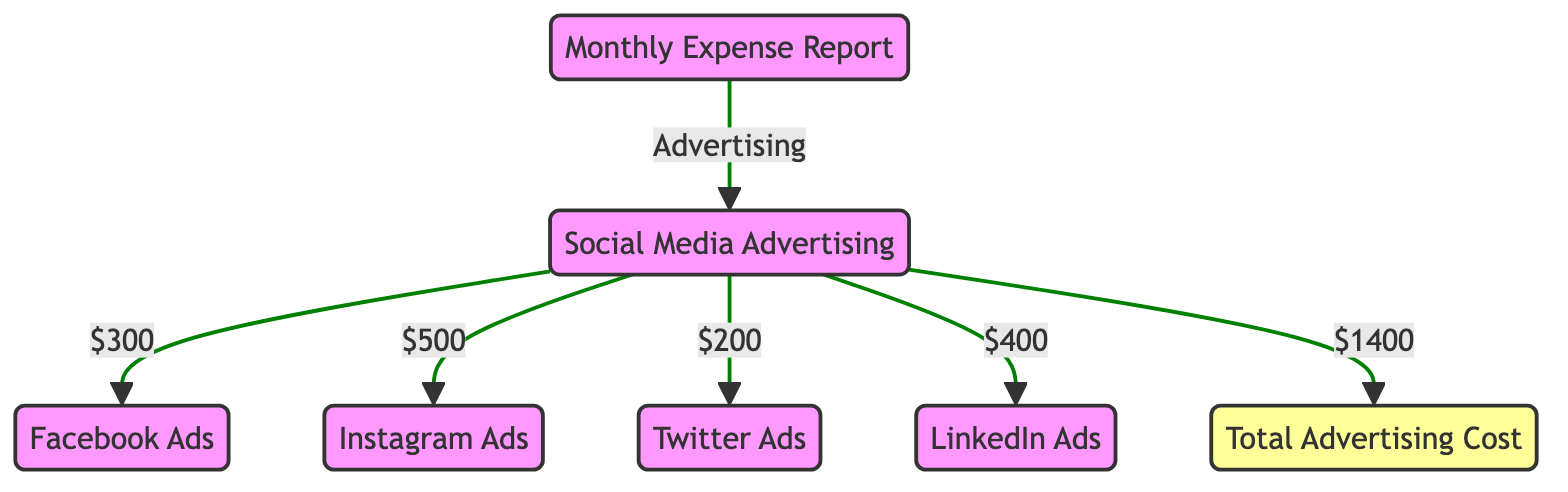What is the total expense listed for social media advertising? The diagram indicates that the total expense for social media advertising is represented as $1400 at the total expense node.
Answer: $1400 What is the expense for Instagram ads? In the diagram, the Instagram ads expense is explicitly shown to be $500 at the corresponding node.
Answer: $500 How many types of social media advertising costs are represented in the diagram? The diagram includes four types of social media advertising expenses: Facebook Ads, Instagram Ads, Twitter Ads, and LinkedIn Ads, totaling four nodes.
Answer: 4 Which social media platform has the highest advertising cost? By comparing the values provided in the diagram for each platform, LinkedIn ads show the highest cost at $400.
Answer: LinkedIn Ads What is the relationship between social media advertising and total advertising cost? The diagram shows that social media advertising is a category that leads to the total advertising cost, indicating that all specific expenses contribute to this total.
Answer: Contributes What is the total amount spent on Facebook ads and Twitter ads combined? To find the combined amount, add Facebook Ads ($300) and Twitter Ads ($200) together, resulting in $500.
Answer: $500 Is the expense for Instagram ads higher than that of Twitter ads? By comparing the expenses given, Instagram ads cost $500 while Twitter ads cost $200, thus indicating that Instagram ads are indeed higher.
Answer: Yes How much is spent on Facebook Ads? The diagram clearly indicates that the expense for Facebook Ads is $300.
Answer: $300 What is the lowest expense listed for social media advertising? By reviewing each expense in the diagram, Twitter ads are the lowest at $200.
Answer: $200 